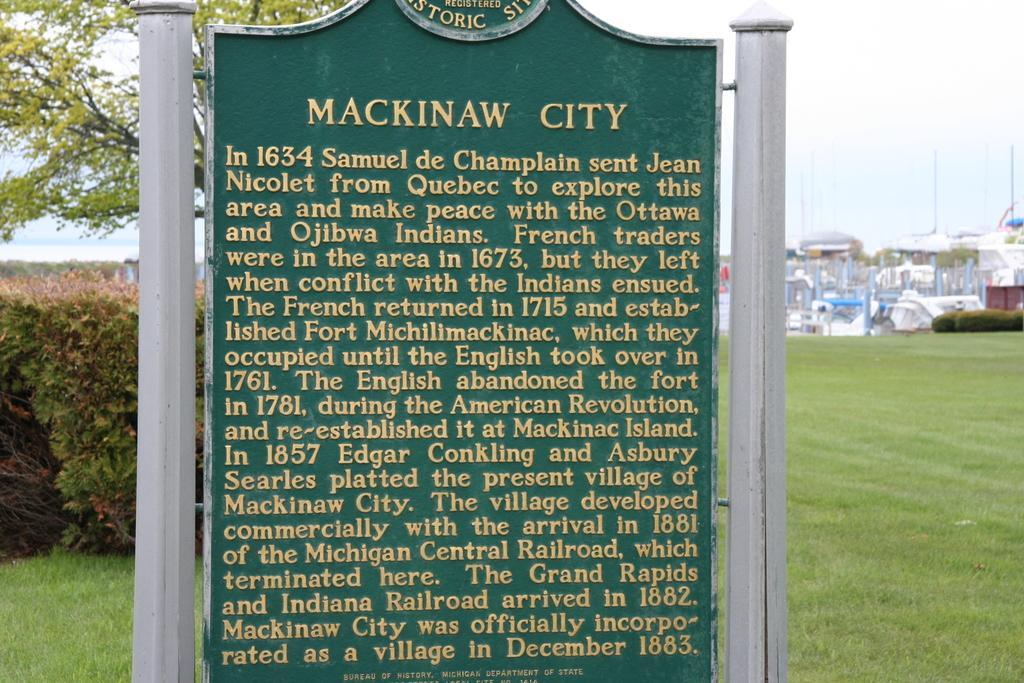Could you give a brief overview of what you see in this image? In this picture we can see some text on a green board. We can see some grass on the ground. There are a few bushes and a tree is visible on the left side. We can see some bushes on the right side. There are a few objects visible in the background. 